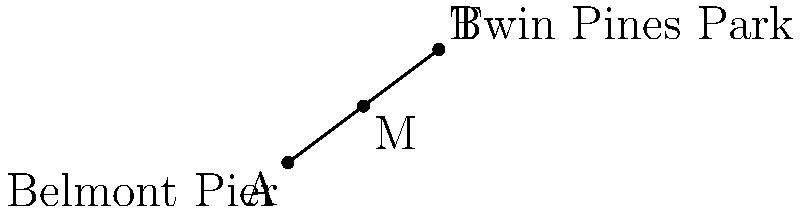From your patio, you observe two prominent landmarks along the Belmont coastline: the Belmont Pier at coordinates $(0,0)$ and Twin Pines Park at $(8,6)$. You're interested in finding a point exactly halfway between these two locations. What are the coordinates of this midpoint? To find the midpoint of a line segment, we can use the midpoint formula:

$$ M_x = \frac{x_1 + x_2}{2}, \quad M_y = \frac{y_1 + y_2}{2} $$

Where $(x_1, y_1)$ are the coordinates of the first point and $(x_2, y_2)$ are the coordinates of the second point.

1. Identify the coordinates:
   - Belmont Pier: $(x_1, y_1) = (0, 0)$
   - Twin Pines Park: $(x_2, y_2) = (8, 6)$

2. Calculate the x-coordinate of the midpoint:
   $$ M_x = \frac{x_1 + x_2}{2} = \frac{0 + 8}{2} = \frac{8}{2} = 4 $$

3. Calculate the y-coordinate of the midpoint:
   $$ M_y = \frac{y_1 + y_2}{2} = \frac{0 + 6}{2} = \frac{6}{2} = 3 $$

4. Combine the results to get the midpoint coordinates: $(4, 3)$
Answer: $(4, 3)$ 